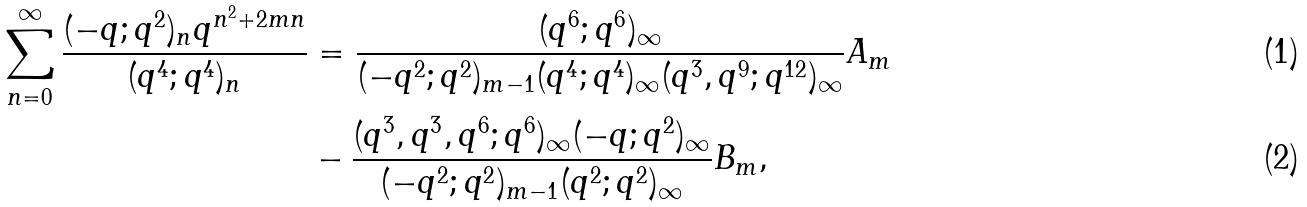Convert formula to latex. <formula><loc_0><loc_0><loc_500><loc_500>\sum _ { n = 0 } ^ { \infty } \frac { ( - q ; q ^ { 2 } ) _ { n } q ^ { n ^ { 2 } + 2 m n } } { ( q ^ { 4 } ; q ^ { 4 } ) _ { n } } & = \frac { ( q ^ { 6 } ; q ^ { 6 } ) _ { \infty } } { ( - q ^ { 2 } ; q ^ { 2 } ) _ { m - 1 } ( q ^ { 4 } ; q ^ { 4 } ) _ { \infty } ( q ^ { 3 } , q ^ { 9 } ; q ^ { 1 2 } ) _ { \infty } } A _ { m } \\ & - \frac { ( q ^ { 3 } , q ^ { 3 } , q ^ { 6 } ; q ^ { 6 } ) _ { \infty } ( - q ; q ^ { 2 } ) _ { \infty } } { ( - q ^ { 2 } ; q ^ { 2 } ) _ { m - 1 } ( q ^ { 2 } ; q ^ { 2 } ) _ { \infty } } B _ { m } ,</formula> 